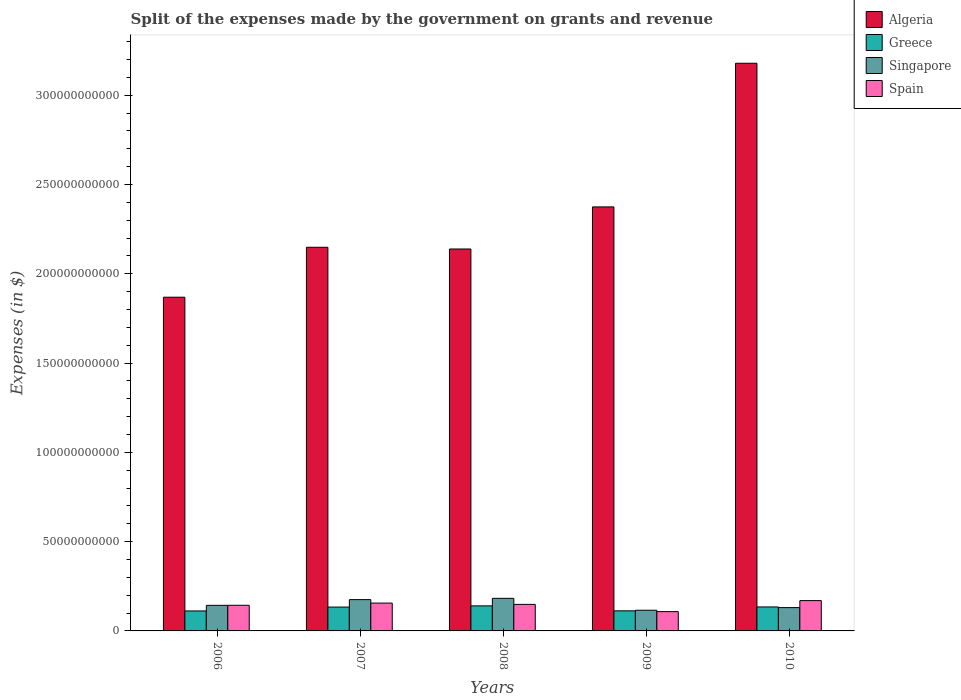How many different coloured bars are there?
Your answer should be compact. 4. How many groups of bars are there?
Your answer should be very brief. 5. Are the number of bars per tick equal to the number of legend labels?
Your answer should be compact. Yes. Are the number of bars on each tick of the X-axis equal?
Make the answer very short. Yes. How many bars are there on the 5th tick from the left?
Offer a very short reply. 4. How many bars are there on the 3rd tick from the right?
Your answer should be very brief. 4. What is the label of the 4th group of bars from the left?
Keep it short and to the point. 2009. In how many cases, is the number of bars for a given year not equal to the number of legend labels?
Your response must be concise. 0. What is the expenses made by the government on grants and revenue in Greece in 2008?
Your answer should be compact. 1.40e+1. Across all years, what is the maximum expenses made by the government on grants and revenue in Spain?
Ensure brevity in your answer.  1.70e+1. Across all years, what is the minimum expenses made by the government on grants and revenue in Singapore?
Your answer should be compact. 1.16e+1. In which year was the expenses made by the government on grants and revenue in Greece minimum?
Your response must be concise. 2006. What is the total expenses made by the government on grants and revenue in Singapore in the graph?
Make the answer very short. 7.47e+1. What is the difference between the expenses made by the government on grants and revenue in Spain in 2007 and that in 2009?
Provide a short and direct response. 4.79e+09. What is the difference between the expenses made by the government on grants and revenue in Singapore in 2008 and the expenses made by the government on grants and revenue in Spain in 2009?
Provide a short and direct response. 7.44e+09. What is the average expenses made by the government on grants and revenue in Algeria per year?
Give a very brief answer. 2.34e+11. In the year 2010, what is the difference between the expenses made by the government on grants and revenue in Spain and expenses made by the government on grants and revenue in Algeria?
Keep it short and to the point. -3.01e+11. In how many years, is the expenses made by the government on grants and revenue in Greece greater than 60000000000 $?
Keep it short and to the point. 0. What is the ratio of the expenses made by the government on grants and revenue in Spain in 2007 to that in 2009?
Provide a succinct answer. 1.44. What is the difference between the highest and the second highest expenses made by the government on grants and revenue in Singapore?
Provide a short and direct response. 7.12e+08. What is the difference between the highest and the lowest expenses made by the government on grants and revenue in Spain?
Give a very brief answer. 6.18e+09. In how many years, is the expenses made by the government on grants and revenue in Greece greater than the average expenses made by the government on grants and revenue in Greece taken over all years?
Give a very brief answer. 3. Is the sum of the expenses made by the government on grants and revenue in Algeria in 2006 and 2009 greater than the maximum expenses made by the government on grants and revenue in Spain across all years?
Provide a short and direct response. Yes. What does the 4th bar from the left in 2007 represents?
Provide a short and direct response. Spain. What does the 2nd bar from the right in 2006 represents?
Provide a succinct answer. Singapore. Is it the case that in every year, the sum of the expenses made by the government on grants and revenue in Greece and expenses made by the government on grants and revenue in Spain is greater than the expenses made by the government on grants and revenue in Singapore?
Offer a very short reply. Yes. How many bars are there?
Offer a very short reply. 20. Are all the bars in the graph horizontal?
Make the answer very short. No. Are the values on the major ticks of Y-axis written in scientific E-notation?
Your answer should be compact. No. How many legend labels are there?
Keep it short and to the point. 4. How are the legend labels stacked?
Offer a very short reply. Vertical. What is the title of the graph?
Offer a very short reply. Split of the expenses made by the government on grants and revenue. What is the label or title of the Y-axis?
Offer a terse response. Expenses (in $). What is the Expenses (in $) of Algeria in 2006?
Provide a succinct answer. 1.87e+11. What is the Expenses (in $) in Greece in 2006?
Your answer should be compact. 1.12e+1. What is the Expenses (in $) in Singapore in 2006?
Your response must be concise. 1.43e+1. What is the Expenses (in $) in Spain in 2006?
Provide a short and direct response. 1.44e+1. What is the Expenses (in $) in Algeria in 2007?
Keep it short and to the point. 2.15e+11. What is the Expenses (in $) in Greece in 2007?
Keep it short and to the point. 1.34e+1. What is the Expenses (in $) of Singapore in 2007?
Offer a terse response. 1.75e+1. What is the Expenses (in $) in Spain in 2007?
Offer a very short reply. 1.56e+1. What is the Expenses (in $) in Algeria in 2008?
Make the answer very short. 2.14e+11. What is the Expenses (in $) in Greece in 2008?
Your answer should be compact. 1.40e+1. What is the Expenses (in $) of Singapore in 2008?
Provide a short and direct response. 1.82e+1. What is the Expenses (in $) in Spain in 2008?
Provide a succinct answer. 1.49e+1. What is the Expenses (in $) of Algeria in 2009?
Make the answer very short. 2.37e+11. What is the Expenses (in $) in Greece in 2009?
Provide a succinct answer. 1.13e+1. What is the Expenses (in $) in Singapore in 2009?
Make the answer very short. 1.16e+1. What is the Expenses (in $) in Spain in 2009?
Make the answer very short. 1.08e+1. What is the Expenses (in $) in Algeria in 2010?
Offer a very short reply. 3.18e+11. What is the Expenses (in $) in Greece in 2010?
Keep it short and to the point. 1.34e+1. What is the Expenses (in $) of Singapore in 2010?
Your answer should be very brief. 1.31e+1. What is the Expenses (in $) in Spain in 2010?
Give a very brief answer. 1.70e+1. Across all years, what is the maximum Expenses (in $) of Algeria?
Offer a very short reply. 3.18e+11. Across all years, what is the maximum Expenses (in $) in Greece?
Ensure brevity in your answer.  1.40e+1. Across all years, what is the maximum Expenses (in $) of Singapore?
Give a very brief answer. 1.82e+1. Across all years, what is the maximum Expenses (in $) in Spain?
Offer a very short reply. 1.70e+1. Across all years, what is the minimum Expenses (in $) of Algeria?
Offer a very short reply. 1.87e+11. Across all years, what is the minimum Expenses (in $) of Greece?
Make the answer very short. 1.12e+1. Across all years, what is the minimum Expenses (in $) in Singapore?
Your answer should be very brief. 1.16e+1. Across all years, what is the minimum Expenses (in $) of Spain?
Provide a succinct answer. 1.08e+1. What is the total Expenses (in $) in Algeria in the graph?
Your answer should be compact. 1.17e+12. What is the total Expenses (in $) in Greece in the graph?
Your answer should be compact. 6.33e+1. What is the total Expenses (in $) of Singapore in the graph?
Ensure brevity in your answer.  7.47e+1. What is the total Expenses (in $) of Spain in the graph?
Provide a short and direct response. 7.26e+1. What is the difference between the Expenses (in $) of Algeria in 2006 and that in 2007?
Provide a short and direct response. -2.80e+1. What is the difference between the Expenses (in $) of Greece in 2006 and that in 2007?
Provide a short and direct response. -2.17e+09. What is the difference between the Expenses (in $) of Singapore in 2006 and that in 2007?
Provide a succinct answer. -3.21e+09. What is the difference between the Expenses (in $) of Spain in 2006 and that in 2007?
Provide a short and direct response. -1.22e+09. What is the difference between the Expenses (in $) in Algeria in 2006 and that in 2008?
Keep it short and to the point. -2.70e+1. What is the difference between the Expenses (in $) of Greece in 2006 and that in 2008?
Make the answer very short. -2.84e+09. What is the difference between the Expenses (in $) in Singapore in 2006 and that in 2008?
Provide a short and direct response. -3.92e+09. What is the difference between the Expenses (in $) of Spain in 2006 and that in 2008?
Your answer should be very brief. -4.91e+08. What is the difference between the Expenses (in $) in Algeria in 2006 and that in 2009?
Offer a terse response. -5.06e+1. What is the difference between the Expenses (in $) in Greece in 2006 and that in 2009?
Your response must be concise. -6.30e+07. What is the difference between the Expenses (in $) of Singapore in 2006 and that in 2009?
Offer a very short reply. 2.75e+09. What is the difference between the Expenses (in $) of Spain in 2006 and that in 2009?
Offer a very short reply. 3.57e+09. What is the difference between the Expenses (in $) in Algeria in 2006 and that in 2010?
Give a very brief answer. -1.31e+11. What is the difference between the Expenses (in $) of Greece in 2006 and that in 2010?
Your response must be concise. -2.24e+09. What is the difference between the Expenses (in $) of Singapore in 2006 and that in 2010?
Provide a succinct answer. 1.27e+09. What is the difference between the Expenses (in $) in Spain in 2006 and that in 2010?
Offer a very short reply. -2.62e+09. What is the difference between the Expenses (in $) of Algeria in 2007 and that in 2008?
Make the answer very short. 9.60e+08. What is the difference between the Expenses (in $) in Greece in 2007 and that in 2008?
Your response must be concise. -6.71e+08. What is the difference between the Expenses (in $) in Singapore in 2007 and that in 2008?
Offer a terse response. -7.12e+08. What is the difference between the Expenses (in $) of Spain in 2007 and that in 2008?
Make the answer very short. 7.33e+08. What is the difference between the Expenses (in $) of Algeria in 2007 and that in 2009?
Your answer should be very brief. -2.26e+1. What is the difference between the Expenses (in $) of Greece in 2007 and that in 2009?
Ensure brevity in your answer.  2.11e+09. What is the difference between the Expenses (in $) in Singapore in 2007 and that in 2009?
Make the answer very short. 5.96e+09. What is the difference between the Expenses (in $) of Spain in 2007 and that in 2009?
Make the answer very short. 4.79e+09. What is the difference between the Expenses (in $) of Algeria in 2007 and that in 2010?
Your answer should be compact. -1.03e+11. What is the difference between the Expenses (in $) of Greece in 2007 and that in 2010?
Give a very brief answer. -6.40e+07. What is the difference between the Expenses (in $) in Singapore in 2007 and that in 2010?
Offer a very short reply. 4.48e+09. What is the difference between the Expenses (in $) in Spain in 2007 and that in 2010?
Offer a very short reply. -1.39e+09. What is the difference between the Expenses (in $) of Algeria in 2008 and that in 2009?
Give a very brief answer. -2.36e+1. What is the difference between the Expenses (in $) in Greece in 2008 and that in 2009?
Your answer should be compact. 2.78e+09. What is the difference between the Expenses (in $) in Singapore in 2008 and that in 2009?
Offer a very short reply. 6.67e+09. What is the difference between the Expenses (in $) of Spain in 2008 and that in 2009?
Provide a succinct answer. 4.06e+09. What is the difference between the Expenses (in $) in Algeria in 2008 and that in 2010?
Your answer should be compact. -1.04e+11. What is the difference between the Expenses (in $) in Greece in 2008 and that in 2010?
Make the answer very short. 6.07e+08. What is the difference between the Expenses (in $) in Singapore in 2008 and that in 2010?
Your response must be concise. 5.19e+09. What is the difference between the Expenses (in $) in Spain in 2008 and that in 2010?
Provide a short and direct response. -2.12e+09. What is the difference between the Expenses (in $) in Algeria in 2009 and that in 2010?
Provide a short and direct response. -8.04e+1. What is the difference between the Expenses (in $) of Greece in 2009 and that in 2010?
Your answer should be very brief. -2.17e+09. What is the difference between the Expenses (in $) of Singapore in 2009 and that in 2010?
Keep it short and to the point. -1.48e+09. What is the difference between the Expenses (in $) in Spain in 2009 and that in 2010?
Provide a short and direct response. -6.18e+09. What is the difference between the Expenses (in $) in Algeria in 2006 and the Expenses (in $) in Greece in 2007?
Make the answer very short. 1.74e+11. What is the difference between the Expenses (in $) in Algeria in 2006 and the Expenses (in $) in Singapore in 2007?
Your response must be concise. 1.69e+11. What is the difference between the Expenses (in $) in Algeria in 2006 and the Expenses (in $) in Spain in 2007?
Your response must be concise. 1.71e+11. What is the difference between the Expenses (in $) in Greece in 2006 and the Expenses (in $) in Singapore in 2007?
Keep it short and to the point. -6.35e+09. What is the difference between the Expenses (in $) in Greece in 2006 and the Expenses (in $) in Spain in 2007?
Your answer should be very brief. -4.40e+09. What is the difference between the Expenses (in $) of Singapore in 2006 and the Expenses (in $) of Spain in 2007?
Offer a very short reply. -1.26e+09. What is the difference between the Expenses (in $) in Algeria in 2006 and the Expenses (in $) in Greece in 2008?
Your answer should be very brief. 1.73e+11. What is the difference between the Expenses (in $) in Algeria in 2006 and the Expenses (in $) in Singapore in 2008?
Offer a terse response. 1.69e+11. What is the difference between the Expenses (in $) of Algeria in 2006 and the Expenses (in $) of Spain in 2008?
Ensure brevity in your answer.  1.72e+11. What is the difference between the Expenses (in $) in Greece in 2006 and the Expenses (in $) in Singapore in 2008?
Your answer should be compact. -7.06e+09. What is the difference between the Expenses (in $) of Greece in 2006 and the Expenses (in $) of Spain in 2008?
Provide a succinct answer. -3.67e+09. What is the difference between the Expenses (in $) of Singapore in 2006 and the Expenses (in $) of Spain in 2008?
Provide a succinct answer. -5.32e+08. What is the difference between the Expenses (in $) in Algeria in 2006 and the Expenses (in $) in Greece in 2009?
Your answer should be very brief. 1.76e+11. What is the difference between the Expenses (in $) of Algeria in 2006 and the Expenses (in $) of Singapore in 2009?
Ensure brevity in your answer.  1.75e+11. What is the difference between the Expenses (in $) in Algeria in 2006 and the Expenses (in $) in Spain in 2009?
Provide a short and direct response. 1.76e+11. What is the difference between the Expenses (in $) of Greece in 2006 and the Expenses (in $) of Singapore in 2009?
Ensure brevity in your answer.  -3.89e+08. What is the difference between the Expenses (in $) of Greece in 2006 and the Expenses (in $) of Spain in 2009?
Your answer should be very brief. 3.87e+08. What is the difference between the Expenses (in $) of Singapore in 2006 and the Expenses (in $) of Spain in 2009?
Provide a short and direct response. 3.52e+09. What is the difference between the Expenses (in $) of Algeria in 2006 and the Expenses (in $) of Greece in 2010?
Keep it short and to the point. 1.73e+11. What is the difference between the Expenses (in $) of Algeria in 2006 and the Expenses (in $) of Singapore in 2010?
Your answer should be very brief. 1.74e+11. What is the difference between the Expenses (in $) in Algeria in 2006 and the Expenses (in $) in Spain in 2010?
Give a very brief answer. 1.70e+11. What is the difference between the Expenses (in $) in Greece in 2006 and the Expenses (in $) in Singapore in 2010?
Your answer should be compact. -1.87e+09. What is the difference between the Expenses (in $) in Greece in 2006 and the Expenses (in $) in Spain in 2010?
Your answer should be compact. -5.80e+09. What is the difference between the Expenses (in $) of Singapore in 2006 and the Expenses (in $) of Spain in 2010?
Give a very brief answer. -2.66e+09. What is the difference between the Expenses (in $) of Algeria in 2007 and the Expenses (in $) of Greece in 2008?
Your response must be concise. 2.01e+11. What is the difference between the Expenses (in $) in Algeria in 2007 and the Expenses (in $) in Singapore in 2008?
Keep it short and to the point. 1.97e+11. What is the difference between the Expenses (in $) in Algeria in 2007 and the Expenses (in $) in Spain in 2008?
Offer a very short reply. 2.00e+11. What is the difference between the Expenses (in $) of Greece in 2007 and the Expenses (in $) of Singapore in 2008?
Give a very brief answer. -4.88e+09. What is the difference between the Expenses (in $) of Greece in 2007 and the Expenses (in $) of Spain in 2008?
Your answer should be very brief. -1.50e+09. What is the difference between the Expenses (in $) of Singapore in 2007 and the Expenses (in $) of Spain in 2008?
Offer a very short reply. 2.68e+09. What is the difference between the Expenses (in $) in Algeria in 2007 and the Expenses (in $) in Greece in 2009?
Make the answer very short. 2.04e+11. What is the difference between the Expenses (in $) in Algeria in 2007 and the Expenses (in $) in Singapore in 2009?
Your response must be concise. 2.03e+11. What is the difference between the Expenses (in $) of Algeria in 2007 and the Expenses (in $) of Spain in 2009?
Provide a succinct answer. 2.04e+11. What is the difference between the Expenses (in $) in Greece in 2007 and the Expenses (in $) in Singapore in 2009?
Your response must be concise. 1.78e+09. What is the difference between the Expenses (in $) of Greece in 2007 and the Expenses (in $) of Spain in 2009?
Give a very brief answer. 2.56e+09. What is the difference between the Expenses (in $) in Singapore in 2007 and the Expenses (in $) in Spain in 2009?
Provide a short and direct response. 6.73e+09. What is the difference between the Expenses (in $) in Algeria in 2007 and the Expenses (in $) in Greece in 2010?
Ensure brevity in your answer.  2.01e+11. What is the difference between the Expenses (in $) of Algeria in 2007 and the Expenses (in $) of Singapore in 2010?
Offer a terse response. 2.02e+11. What is the difference between the Expenses (in $) of Algeria in 2007 and the Expenses (in $) of Spain in 2010?
Your answer should be very brief. 1.98e+11. What is the difference between the Expenses (in $) in Greece in 2007 and the Expenses (in $) in Singapore in 2010?
Keep it short and to the point. 3.04e+08. What is the difference between the Expenses (in $) in Greece in 2007 and the Expenses (in $) in Spain in 2010?
Your answer should be very brief. -3.62e+09. What is the difference between the Expenses (in $) of Singapore in 2007 and the Expenses (in $) of Spain in 2010?
Ensure brevity in your answer.  5.51e+08. What is the difference between the Expenses (in $) in Algeria in 2008 and the Expenses (in $) in Greece in 2009?
Your answer should be compact. 2.03e+11. What is the difference between the Expenses (in $) in Algeria in 2008 and the Expenses (in $) in Singapore in 2009?
Your response must be concise. 2.02e+11. What is the difference between the Expenses (in $) in Algeria in 2008 and the Expenses (in $) in Spain in 2009?
Provide a short and direct response. 2.03e+11. What is the difference between the Expenses (in $) in Greece in 2008 and the Expenses (in $) in Singapore in 2009?
Provide a succinct answer. 2.46e+09. What is the difference between the Expenses (in $) in Greece in 2008 and the Expenses (in $) in Spain in 2009?
Your answer should be compact. 3.23e+09. What is the difference between the Expenses (in $) in Singapore in 2008 and the Expenses (in $) in Spain in 2009?
Offer a terse response. 7.44e+09. What is the difference between the Expenses (in $) in Algeria in 2008 and the Expenses (in $) in Greece in 2010?
Provide a short and direct response. 2.00e+11. What is the difference between the Expenses (in $) in Algeria in 2008 and the Expenses (in $) in Singapore in 2010?
Your answer should be compact. 2.01e+11. What is the difference between the Expenses (in $) of Algeria in 2008 and the Expenses (in $) of Spain in 2010?
Offer a terse response. 1.97e+11. What is the difference between the Expenses (in $) of Greece in 2008 and the Expenses (in $) of Singapore in 2010?
Ensure brevity in your answer.  9.75e+08. What is the difference between the Expenses (in $) in Greece in 2008 and the Expenses (in $) in Spain in 2010?
Your answer should be very brief. -2.95e+09. What is the difference between the Expenses (in $) in Singapore in 2008 and the Expenses (in $) in Spain in 2010?
Make the answer very short. 1.26e+09. What is the difference between the Expenses (in $) of Algeria in 2009 and the Expenses (in $) of Greece in 2010?
Your response must be concise. 2.24e+11. What is the difference between the Expenses (in $) in Algeria in 2009 and the Expenses (in $) in Singapore in 2010?
Provide a short and direct response. 2.24e+11. What is the difference between the Expenses (in $) of Algeria in 2009 and the Expenses (in $) of Spain in 2010?
Your answer should be compact. 2.20e+11. What is the difference between the Expenses (in $) in Greece in 2009 and the Expenses (in $) in Singapore in 2010?
Your answer should be compact. -1.81e+09. What is the difference between the Expenses (in $) of Greece in 2009 and the Expenses (in $) of Spain in 2010?
Your answer should be compact. -5.73e+09. What is the difference between the Expenses (in $) in Singapore in 2009 and the Expenses (in $) in Spain in 2010?
Offer a terse response. -5.41e+09. What is the average Expenses (in $) in Algeria per year?
Ensure brevity in your answer.  2.34e+11. What is the average Expenses (in $) of Greece per year?
Your answer should be very brief. 1.27e+1. What is the average Expenses (in $) of Singapore per year?
Keep it short and to the point. 1.49e+1. What is the average Expenses (in $) of Spain per year?
Your answer should be very brief. 1.45e+1. In the year 2006, what is the difference between the Expenses (in $) in Algeria and Expenses (in $) in Greece?
Give a very brief answer. 1.76e+11. In the year 2006, what is the difference between the Expenses (in $) of Algeria and Expenses (in $) of Singapore?
Ensure brevity in your answer.  1.73e+11. In the year 2006, what is the difference between the Expenses (in $) of Algeria and Expenses (in $) of Spain?
Your answer should be very brief. 1.73e+11. In the year 2006, what is the difference between the Expenses (in $) of Greece and Expenses (in $) of Singapore?
Provide a short and direct response. -3.14e+09. In the year 2006, what is the difference between the Expenses (in $) of Greece and Expenses (in $) of Spain?
Keep it short and to the point. -3.18e+09. In the year 2006, what is the difference between the Expenses (in $) of Singapore and Expenses (in $) of Spain?
Provide a short and direct response. -4.10e+07. In the year 2007, what is the difference between the Expenses (in $) in Algeria and Expenses (in $) in Greece?
Make the answer very short. 2.01e+11. In the year 2007, what is the difference between the Expenses (in $) in Algeria and Expenses (in $) in Singapore?
Keep it short and to the point. 1.97e+11. In the year 2007, what is the difference between the Expenses (in $) of Algeria and Expenses (in $) of Spain?
Offer a very short reply. 1.99e+11. In the year 2007, what is the difference between the Expenses (in $) in Greece and Expenses (in $) in Singapore?
Keep it short and to the point. -4.17e+09. In the year 2007, what is the difference between the Expenses (in $) in Greece and Expenses (in $) in Spain?
Provide a short and direct response. -2.23e+09. In the year 2007, what is the difference between the Expenses (in $) of Singapore and Expenses (in $) of Spain?
Ensure brevity in your answer.  1.94e+09. In the year 2008, what is the difference between the Expenses (in $) of Algeria and Expenses (in $) of Greece?
Offer a terse response. 2.00e+11. In the year 2008, what is the difference between the Expenses (in $) in Algeria and Expenses (in $) in Singapore?
Make the answer very short. 1.96e+11. In the year 2008, what is the difference between the Expenses (in $) of Algeria and Expenses (in $) of Spain?
Offer a terse response. 1.99e+11. In the year 2008, what is the difference between the Expenses (in $) in Greece and Expenses (in $) in Singapore?
Make the answer very short. -4.21e+09. In the year 2008, what is the difference between the Expenses (in $) of Greece and Expenses (in $) of Spain?
Your response must be concise. -8.26e+08. In the year 2008, what is the difference between the Expenses (in $) in Singapore and Expenses (in $) in Spain?
Your answer should be compact. 3.39e+09. In the year 2009, what is the difference between the Expenses (in $) in Algeria and Expenses (in $) in Greece?
Offer a terse response. 2.26e+11. In the year 2009, what is the difference between the Expenses (in $) in Algeria and Expenses (in $) in Singapore?
Keep it short and to the point. 2.26e+11. In the year 2009, what is the difference between the Expenses (in $) in Algeria and Expenses (in $) in Spain?
Offer a terse response. 2.27e+11. In the year 2009, what is the difference between the Expenses (in $) in Greece and Expenses (in $) in Singapore?
Your response must be concise. -3.26e+08. In the year 2009, what is the difference between the Expenses (in $) in Greece and Expenses (in $) in Spain?
Your answer should be very brief. 4.50e+08. In the year 2009, what is the difference between the Expenses (in $) of Singapore and Expenses (in $) of Spain?
Give a very brief answer. 7.76e+08. In the year 2010, what is the difference between the Expenses (in $) in Algeria and Expenses (in $) in Greece?
Give a very brief answer. 3.04e+11. In the year 2010, what is the difference between the Expenses (in $) of Algeria and Expenses (in $) of Singapore?
Make the answer very short. 3.05e+11. In the year 2010, what is the difference between the Expenses (in $) in Algeria and Expenses (in $) in Spain?
Offer a terse response. 3.01e+11. In the year 2010, what is the difference between the Expenses (in $) of Greece and Expenses (in $) of Singapore?
Make the answer very short. 3.68e+08. In the year 2010, what is the difference between the Expenses (in $) in Greece and Expenses (in $) in Spain?
Provide a short and direct response. -3.56e+09. In the year 2010, what is the difference between the Expenses (in $) of Singapore and Expenses (in $) of Spain?
Your answer should be compact. -3.93e+09. What is the ratio of the Expenses (in $) in Algeria in 2006 to that in 2007?
Give a very brief answer. 0.87. What is the ratio of the Expenses (in $) of Greece in 2006 to that in 2007?
Offer a terse response. 0.84. What is the ratio of the Expenses (in $) in Singapore in 2006 to that in 2007?
Your answer should be very brief. 0.82. What is the ratio of the Expenses (in $) in Spain in 2006 to that in 2007?
Keep it short and to the point. 0.92. What is the ratio of the Expenses (in $) in Algeria in 2006 to that in 2008?
Offer a very short reply. 0.87. What is the ratio of the Expenses (in $) in Greece in 2006 to that in 2008?
Keep it short and to the point. 0.8. What is the ratio of the Expenses (in $) of Singapore in 2006 to that in 2008?
Make the answer very short. 0.79. What is the ratio of the Expenses (in $) of Spain in 2006 to that in 2008?
Give a very brief answer. 0.97. What is the ratio of the Expenses (in $) in Algeria in 2006 to that in 2009?
Your answer should be compact. 0.79. What is the ratio of the Expenses (in $) in Greece in 2006 to that in 2009?
Provide a short and direct response. 0.99. What is the ratio of the Expenses (in $) of Singapore in 2006 to that in 2009?
Give a very brief answer. 1.24. What is the ratio of the Expenses (in $) of Spain in 2006 to that in 2009?
Provide a short and direct response. 1.33. What is the ratio of the Expenses (in $) of Algeria in 2006 to that in 2010?
Give a very brief answer. 0.59. What is the ratio of the Expenses (in $) of Greece in 2006 to that in 2010?
Provide a short and direct response. 0.83. What is the ratio of the Expenses (in $) of Singapore in 2006 to that in 2010?
Make the answer very short. 1.1. What is the ratio of the Expenses (in $) of Spain in 2006 to that in 2010?
Make the answer very short. 0.85. What is the ratio of the Expenses (in $) of Greece in 2007 to that in 2008?
Provide a short and direct response. 0.95. What is the ratio of the Expenses (in $) in Singapore in 2007 to that in 2008?
Provide a short and direct response. 0.96. What is the ratio of the Expenses (in $) of Spain in 2007 to that in 2008?
Your answer should be very brief. 1.05. What is the ratio of the Expenses (in $) of Algeria in 2007 to that in 2009?
Offer a terse response. 0.9. What is the ratio of the Expenses (in $) of Greece in 2007 to that in 2009?
Make the answer very short. 1.19. What is the ratio of the Expenses (in $) in Singapore in 2007 to that in 2009?
Make the answer very short. 1.51. What is the ratio of the Expenses (in $) of Spain in 2007 to that in 2009?
Make the answer very short. 1.44. What is the ratio of the Expenses (in $) of Algeria in 2007 to that in 2010?
Ensure brevity in your answer.  0.68. What is the ratio of the Expenses (in $) of Greece in 2007 to that in 2010?
Your answer should be compact. 1. What is the ratio of the Expenses (in $) of Singapore in 2007 to that in 2010?
Give a very brief answer. 1.34. What is the ratio of the Expenses (in $) in Spain in 2007 to that in 2010?
Keep it short and to the point. 0.92. What is the ratio of the Expenses (in $) of Algeria in 2008 to that in 2009?
Make the answer very short. 0.9. What is the ratio of the Expenses (in $) in Greece in 2008 to that in 2009?
Your answer should be compact. 1.25. What is the ratio of the Expenses (in $) in Singapore in 2008 to that in 2009?
Keep it short and to the point. 1.58. What is the ratio of the Expenses (in $) in Spain in 2008 to that in 2009?
Give a very brief answer. 1.38. What is the ratio of the Expenses (in $) in Algeria in 2008 to that in 2010?
Keep it short and to the point. 0.67. What is the ratio of the Expenses (in $) in Greece in 2008 to that in 2010?
Make the answer very short. 1.05. What is the ratio of the Expenses (in $) in Singapore in 2008 to that in 2010?
Offer a terse response. 1.4. What is the ratio of the Expenses (in $) in Spain in 2008 to that in 2010?
Provide a short and direct response. 0.87. What is the ratio of the Expenses (in $) in Algeria in 2009 to that in 2010?
Give a very brief answer. 0.75. What is the ratio of the Expenses (in $) of Greece in 2009 to that in 2010?
Your answer should be very brief. 0.84. What is the ratio of the Expenses (in $) of Singapore in 2009 to that in 2010?
Keep it short and to the point. 0.89. What is the ratio of the Expenses (in $) of Spain in 2009 to that in 2010?
Provide a succinct answer. 0.64. What is the difference between the highest and the second highest Expenses (in $) of Algeria?
Your answer should be very brief. 8.04e+1. What is the difference between the highest and the second highest Expenses (in $) of Greece?
Give a very brief answer. 6.07e+08. What is the difference between the highest and the second highest Expenses (in $) of Singapore?
Ensure brevity in your answer.  7.12e+08. What is the difference between the highest and the second highest Expenses (in $) of Spain?
Give a very brief answer. 1.39e+09. What is the difference between the highest and the lowest Expenses (in $) of Algeria?
Offer a very short reply. 1.31e+11. What is the difference between the highest and the lowest Expenses (in $) in Greece?
Provide a succinct answer. 2.84e+09. What is the difference between the highest and the lowest Expenses (in $) of Singapore?
Make the answer very short. 6.67e+09. What is the difference between the highest and the lowest Expenses (in $) of Spain?
Your response must be concise. 6.18e+09. 